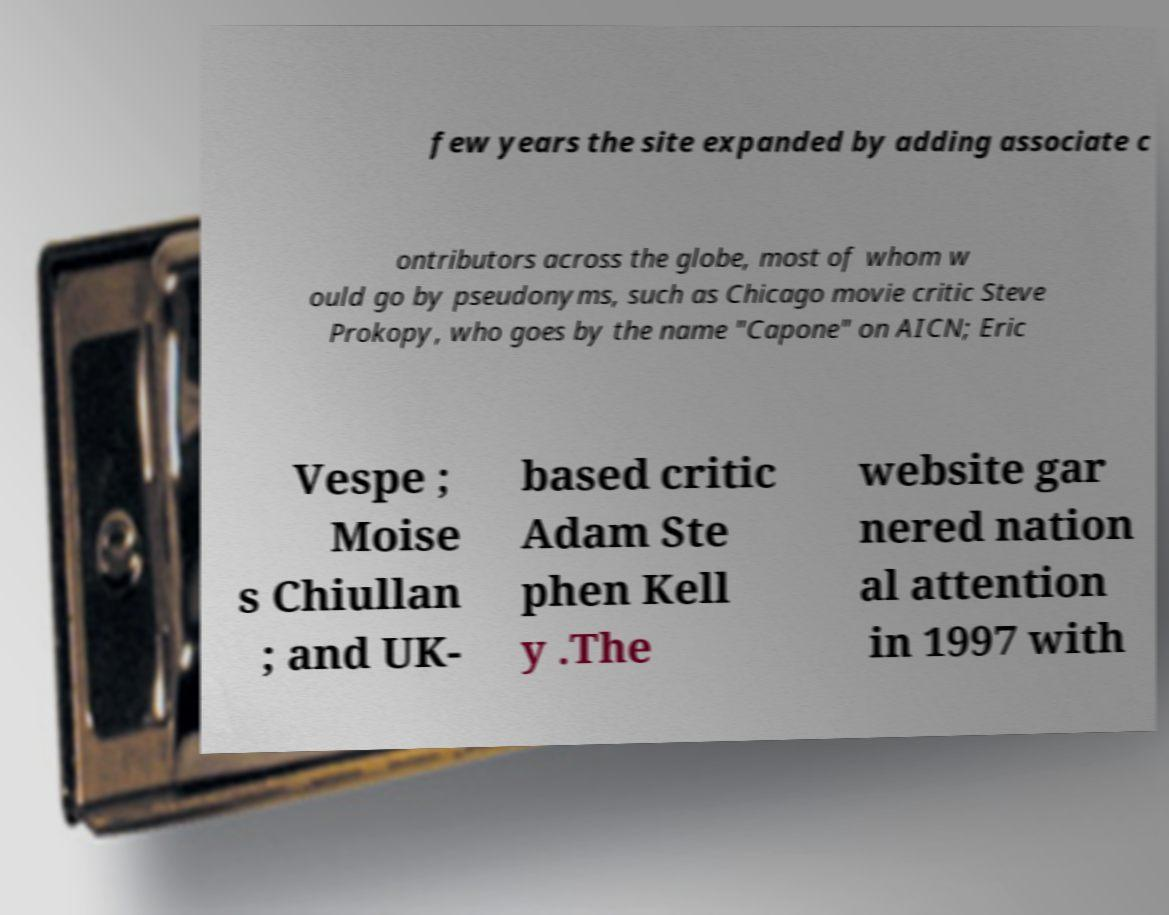I need the written content from this picture converted into text. Can you do that? few years the site expanded by adding associate c ontributors across the globe, most of whom w ould go by pseudonyms, such as Chicago movie critic Steve Prokopy, who goes by the name "Capone" on AICN; Eric Vespe ; Moise s Chiullan ; and UK- based critic Adam Ste phen Kell y .The website gar nered nation al attention in 1997 with 